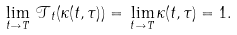<formula> <loc_0><loc_0><loc_500><loc_500>\lim _ { t \to T } \, \mathcal { T } _ { t } ( \kappa ( t , \tau ) ) = \, \lim _ { t \to T } \kappa ( t , \tau ) = 1 .</formula> 